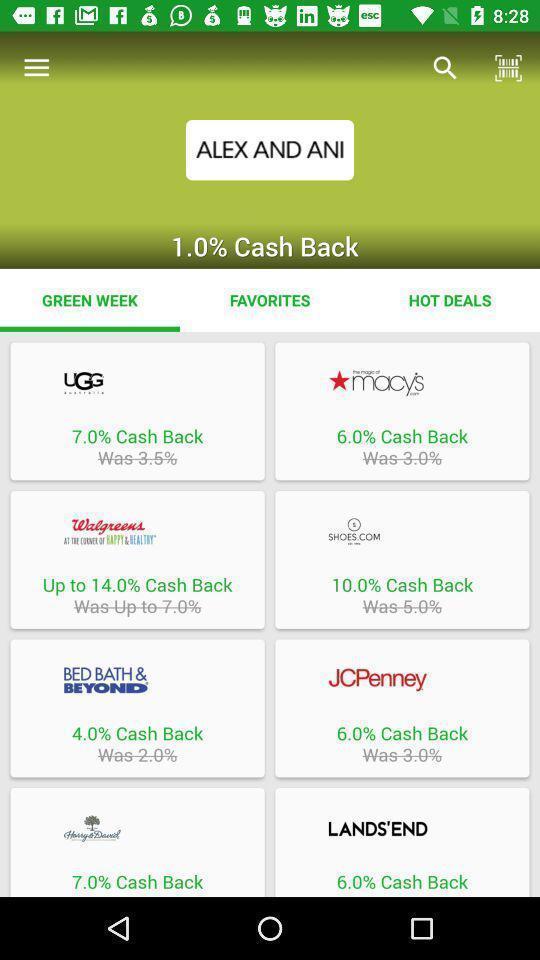Explain what's happening in this screen capture. Screen shows exclusive offers on products in a shopping app. 